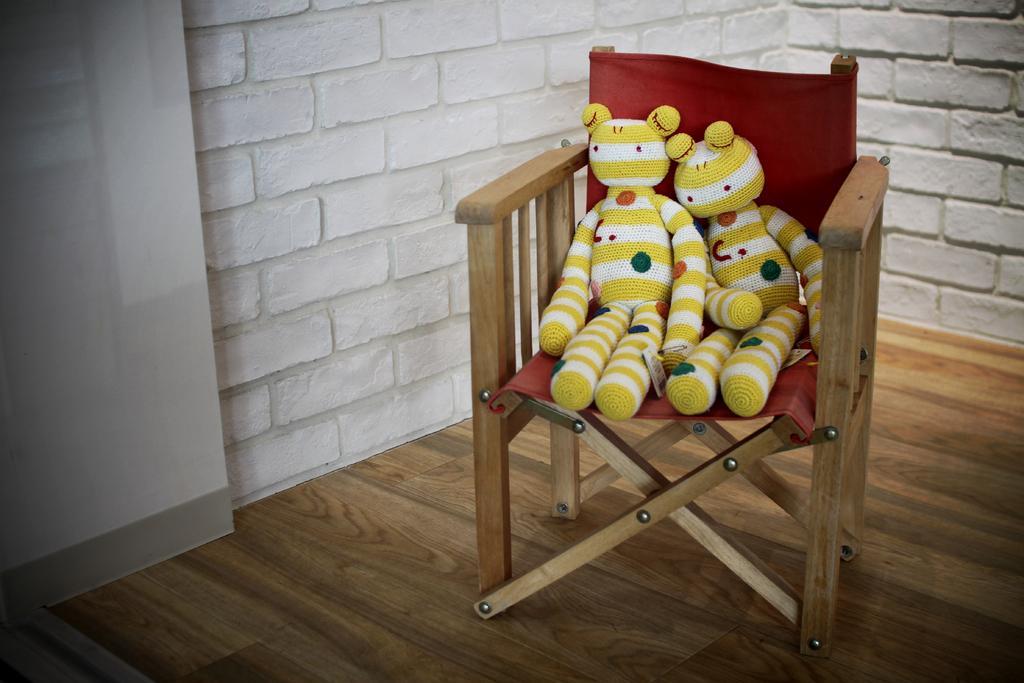Can you describe this image briefly? In the image there are two toys on a chair on the wooden floor and behind it there is wall. 